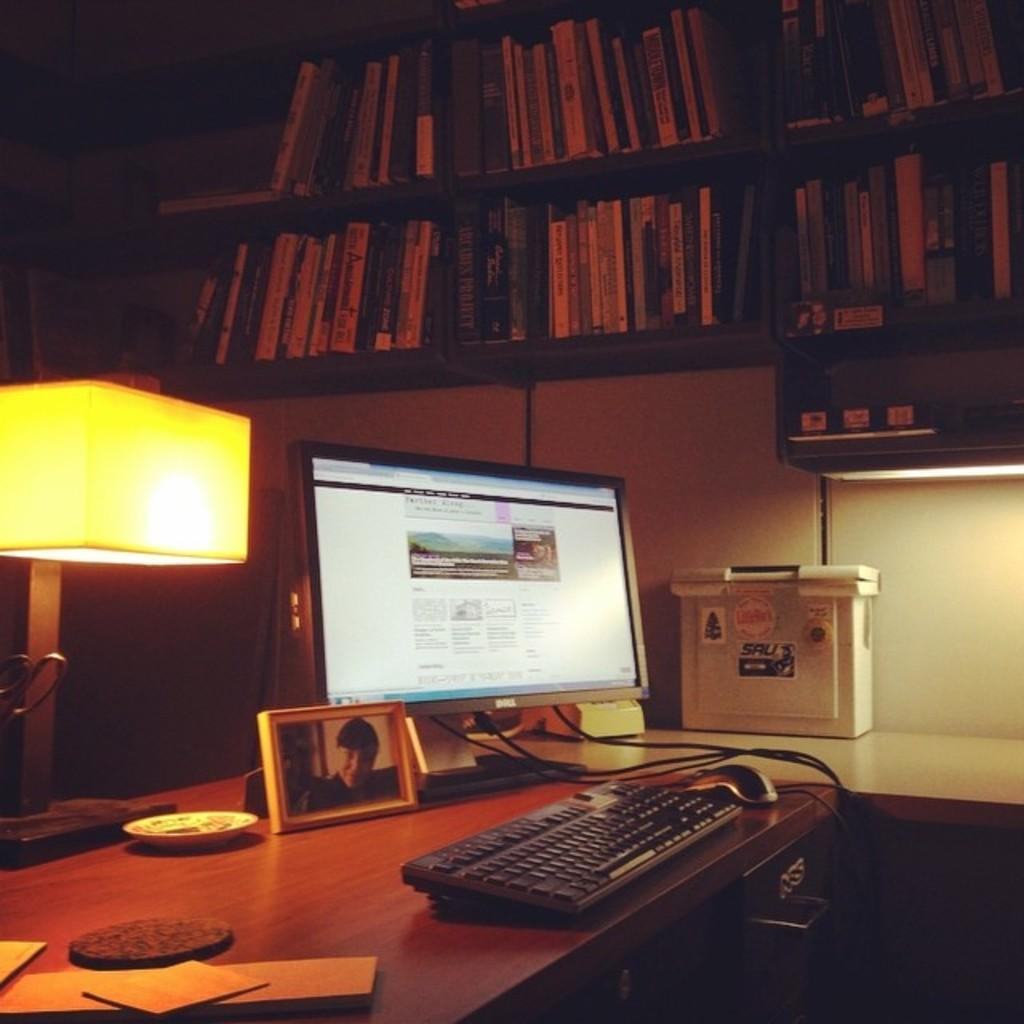What piece of furniture is in the image? There is a table in the image. What electronic device is on the table? A keyboard and a computer are on the table. What decorative item is on the table? There is a photo frame on the table. What type of lighting is near the table? There is a lamp with a yellow color beside the table. What is used for storing items in the image? There is a rack in the image, and books are kept on the rack. Can you see a clam on the table in the image? No, there is no clam present on the table in the image. Is there a kite flying in the background of the image? No, there is no kite visible in the image. 